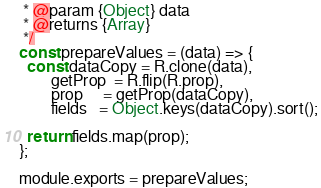<code> <loc_0><loc_0><loc_500><loc_500><_JavaScript_> * @param {Object} data
 * @returns {Array}
 */
const prepareValues = (data) => {
  const dataCopy = R.clone(data),
        getProp  = R.flip(R.prop),
        prop     = getProp(dataCopy),
        fields   = Object.keys(dataCopy).sort();

  return fields.map(prop);
};

module.exports = prepareValues;
</code> 